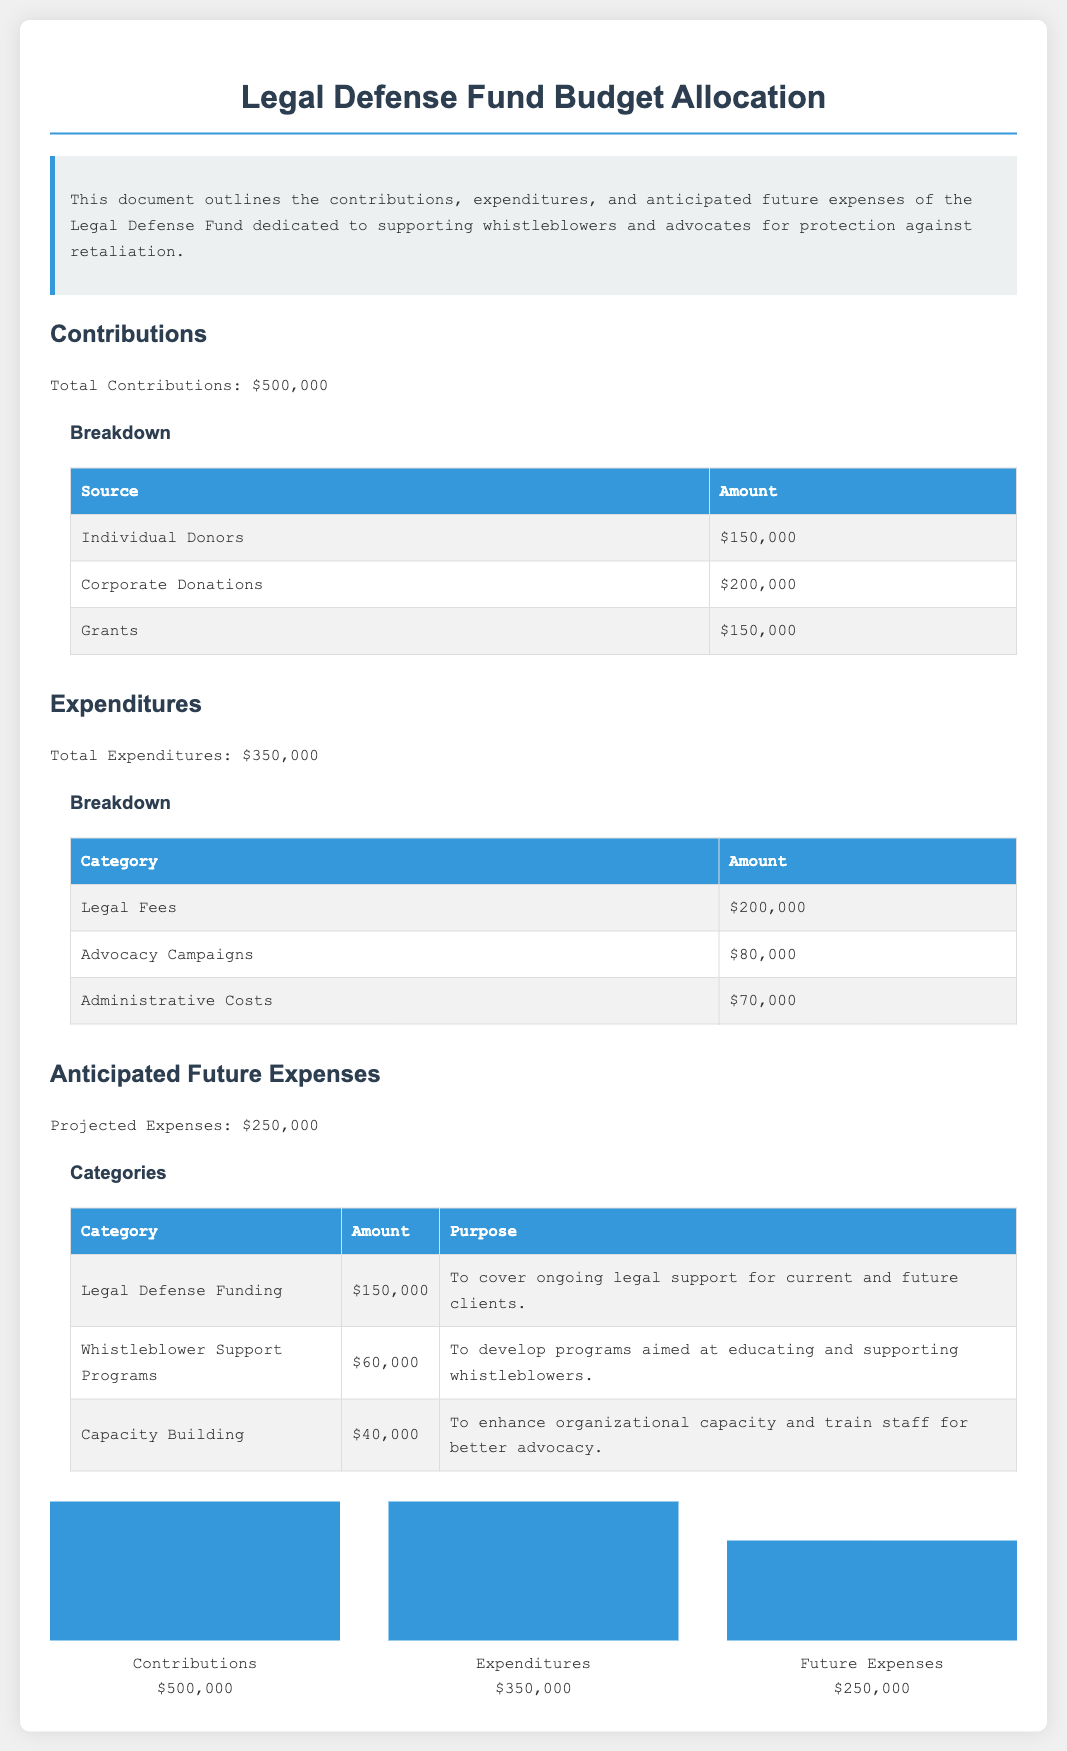What is the total contribution? The total contribution is explicitly stated in the document as $500,000.
Answer: $500,000 What is the amount spent on legal fees? The amount for legal fees is specified in the breakdown of expenditures in the document, which is $200,000.
Answer: $200,000 How much is allocated for future expenses? The projected expenses for anticipated future costs is listed as $250,000 in the document.
Answer: $250,000 What percentage of the contributions was used for expenditures? The percentage is calculated as (Total Expenditures / Total Contributions) * 100 = (350,000 / 500,000) * 100, which is 70%.
Answer: 70% What is the amount set aside for whistleblower support programs? The specific allocation for whistleblower support programs is detailed in the anticipated future expenses section as $60,000.
Answer: $60,000 How many categories are listed under expenditures? The document includes a breakdown of three categories under expenditures: Legal Fees, Advocacy Campaigns, and Administrative Costs.
Answer: 3 What is the total amount from corporate donations? The document specifies that the contribution from corporate donations is $200,000.
Answer: $200,000 What purpose does the capacity building expense serve? The document explains that this expense is aimed at enhancing organizational capacity and training staff for better advocacy.
Answer: To enhance organizational capacity and train staff 